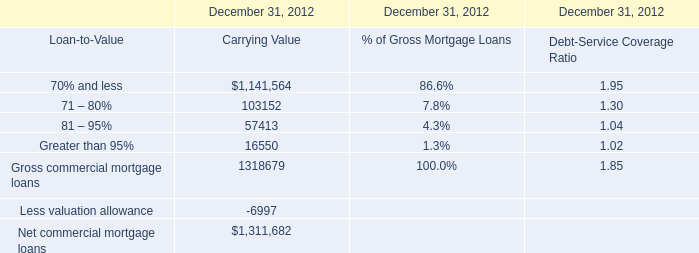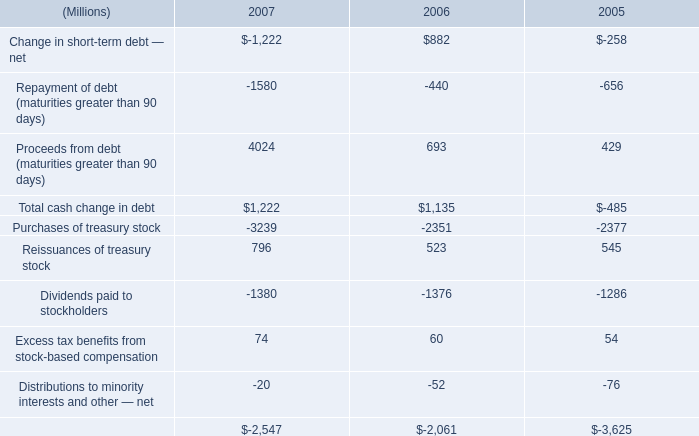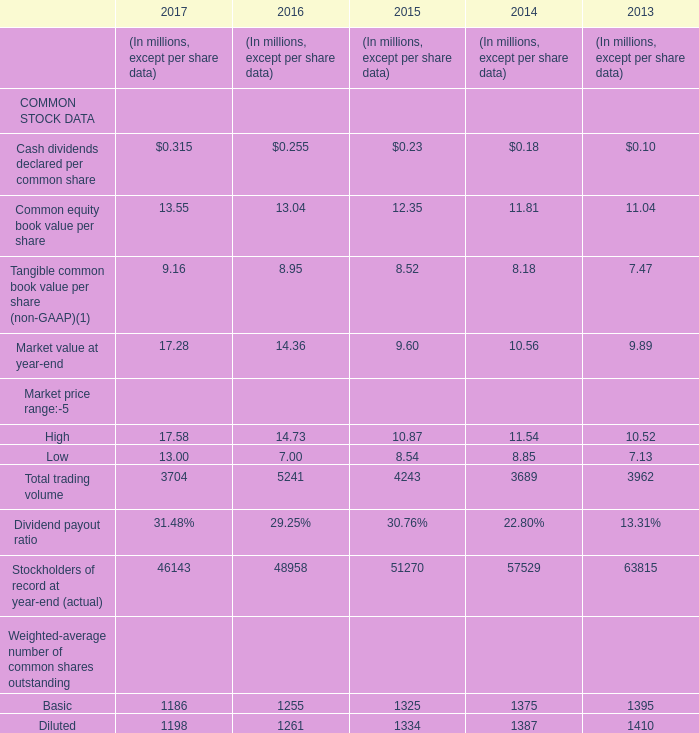What is the Common equity book value per share in 2015? 
Answer: 12.35. 